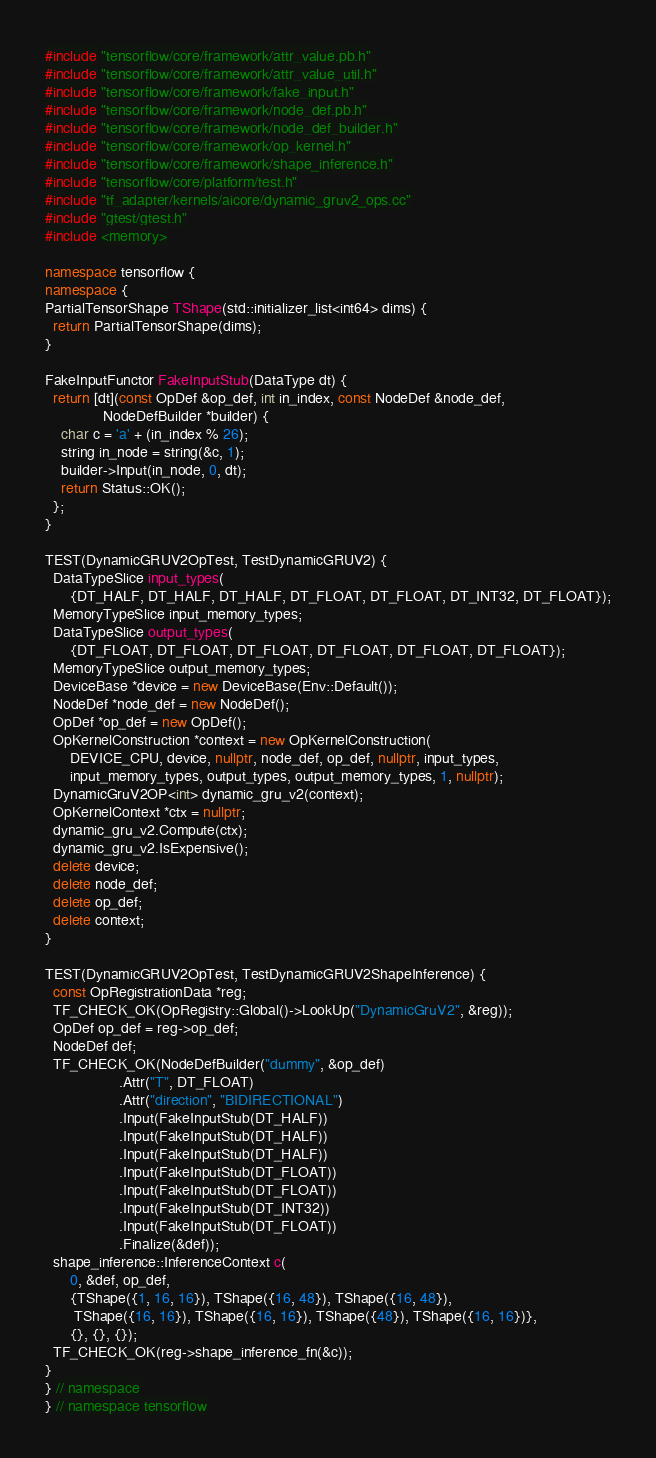<code> <loc_0><loc_0><loc_500><loc_500><_C++_>#include "tensorflow/core/framework/attr_value.pb.h"
#include "tensorflow/core/framework/attr_value_util.h"
#include "tensorflow/core/framework/fake_input.h"
#include "tensorflow/core/framework/node_def.pb.h"
#include "tensorflow/core/framework/node_def_builder.h"
#include "tensorflow/core/framework/op_kernel.h"
#include "tensorflow/core/framework/shape_inference.h"
#include "tensorflow/core/platform/test.h"
#include "tf_adapter/kernels/aicore/dynamic_gruv2_ops.cc"
#include "gtest/gtest.h"
#include <memory>

namespace tensorflow {
namespace {
PartialTensorShape TShape(std::initializer_list<int64> dims) {
  return PartialTensorShape(dims);
}

FakeInputFunctor FakeInputStub(DataType dt) {
  return [dt](const OpDef &op_def, int in_index, const NodeDef &node_def,
              NodeDefBuilder *builder) {
    char c = 'a' + (in_index % 26);
    string in_node = string(&c, 1);
    builder->Input(in_node, 0, dt);
    return Status::OK();
  };
}

TEST(DynamicGRUV2OpTest, TestDynamicGRUV2) {
  DataTypeSlice input_types(
      {DT_HALF, DT_HALF, DT_HALF, DT_FLOAT, DT_FLOAT, DT_INT32, DT_FLOAT});
  MemoryTypeSlice input_memory_types;
  DataTypeSlice output_types(
      {DT_FLOAT, DT_FLOAT, DT_FLOAT, DT_FLOAT, DT_FLOAT, DT_FLOAT});
  MemoryTypeSlice output_memory_types;
  DeviceBase *device = new DeviceBase(Env::Default());
  NodeDef *node_def = new NodeDef();
  OpDef *op_def = new OpDef();
  OpKernelConstruction *context = new OpKernelConstruction(
      DEVICE_CPU, device, nullptr, node_def, op_def, nullptr, input_types,
      input_memory_types, output_types, output_memory_types, 1, nullptr);
  DynamicGruV2OP<int> dynamic_gru_v2(context);
  OpKernelContext *ctx = nullptr;
  dynamic_gru_v2.Compute(ctx);
  dynamic_gru_v2.IsExpensive();
  delete device;
  delete node_def;
  delete op_def;
  delete context;
}

TEST(DynamicGRUV2OpTest, TestDynamicGRUV2ShapeInference) {
  const OpRegistrationData *reg;
  TF_CHECK_OK(OpRegistry::Global()->LookUp("DynamicGruV2", &reg));
  OpDef op_def = reg->op_def;
  NodeDef def;
  TF_CHECK_OK(NodeDefBuilder("dummy", &op_def)
                  .Attr("T", DT_FLOAT)
                  .Attr("direction", "BIDIRECTIONAL")
                  .Input(FakeInputStub(DT_HALF))
                  .Input(FakeInputStub(DT_HALF))
                  .Input(FakeInputStub(DT_HALF))
                  .Input(FakeInputStub(DT_FLOAT))
                  .Input(FakeInputStub(DT_FLOAT))
                  .Input(FakeInputStub(DT_INT32))
                  .Input(FakeInputStub(DT_FLOAT))
                  .Finalize(&def));
  shape_inference::InferenceContext c(
      0, &def, op_def,
      {TShape({1, 16, 16}), TShape({16, 48}), TShape({16, 48}),
       TShape({16, 16}), TShape({16, 16}), TShape({48}), TShape({16, 16})},
      {}, {}, {});
  TF_CHECK_OK(reg->shape_inference_fn(&c));
}
} // namespace
} // namespace tensorflow</code> 